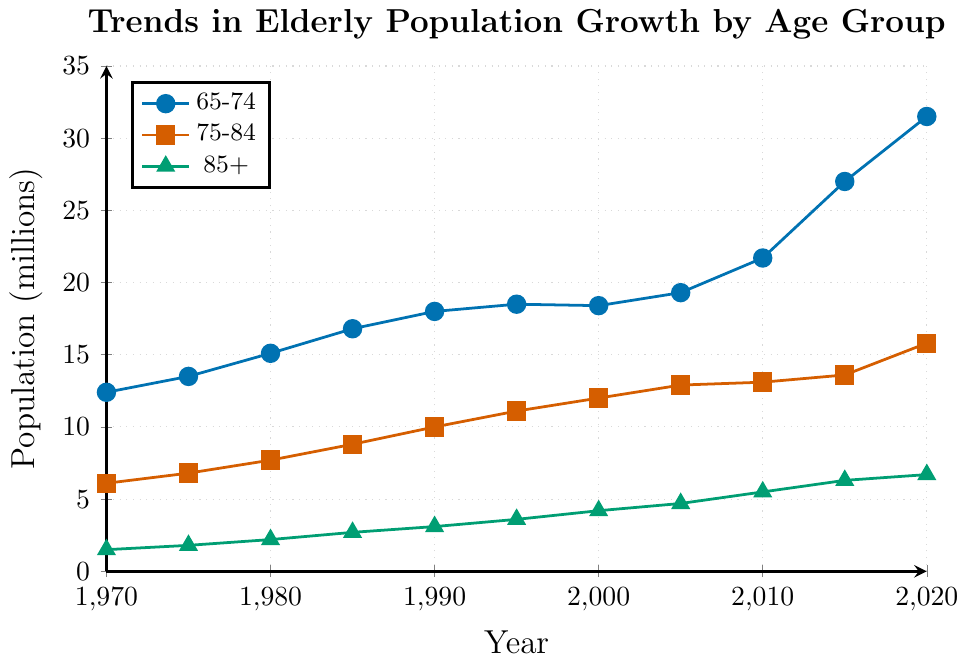What was the population size in the 65-74 age group in 1990? The plot shows the population size data for each age group by year. In 1990, the 65-74 age group population size is at the point plotted in blue.
Answer: 18.0 million Which age group had the largest population increase between 2010 and 2015? To determine the largest population increase, we look at the change in population size between 2010 and 2015 for each age group by examining the vertical distance between the points plotted for these years. The 65-74 age group increased from 21.7 million to 27.0 million.
Answer: 65-74 What is the average population size of the 75-84 age group over all the years? The data for the 75-84 age group is given for multiple years. We calculate the average by summing up all population sizes (6.1 + 6.8 + 7.7 + 8.8 + 10.0 + 11.1 + 12.0 + 12.9 + 13.1 + 13.6 + 15.8) and dividing by the number of years (11). This results in a total of 107.9, so 107.9/11.
Answer: 9.81 million Which age group is represented by the green line in the chart? The legend on the chart explains which color corresponds to which age group. The green line corresponds to the 85+ age group.
Answer: 85+ How much did the population size of the 85+ age group increase from 1970 to 2020? To calculate the increase, we subtract the population size in 1970 from the population size in 2020 for the 85+ age group. The difference is 6.7 million (2020) - 1.5 million (1970).
Answer: 5.2 million In which year did the population of the 65-74 age group first exceed 20 million? By reviewing the plotted points for the 65-74 age group, we see that the population first surpasses 20 million in 2015.
Answer: 2015 Among the three age groups, which has the smallest population size in the year 2000? By comparing the points plotted for the year 2000 across all three age groups, we find that the smallest population size is for the 85+ age group, which is 4.2 million.
Answer: 85+ What was the total population of all three age groups combined in the year 1980? To determine this, we sum the population sizes for each age group in 1980: 15.1 million (65-74) + 7.7 million (75-84) + 2.2 million (85+). The total population is 15.1 + 7.7 + 2.2 = 25.0 million.
Answer: 25.0 million Is the trend of population growth for the 75-84 age group consistent over the years? Observing the orange line representing the 75-84 age group, we see a gradually increasing trend without any major fluctuations, indicating a consistent growth trend.
Answer: Yes Which year saw the highest increase in population for the 65-74 age group within the plotted years? Observing the blue plot points for the 65-74 age group and the distances between them, the largest increase appears between 2010 (21.7 million) and 2015 (27.0 million), which is an increase of 5.3 million.
Answer: 2015 